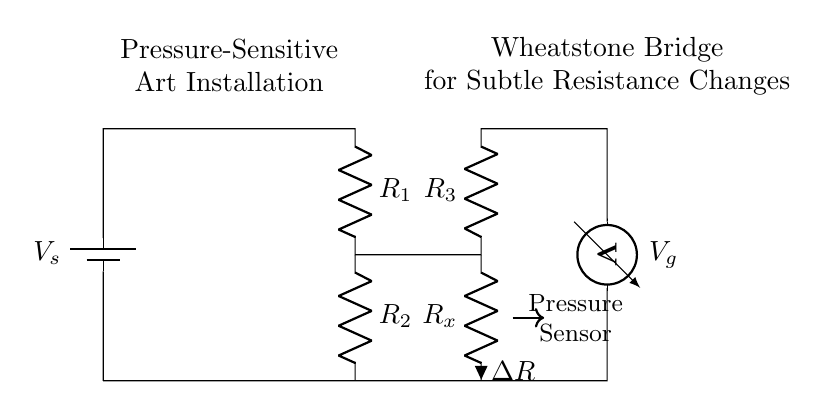What is the symbol for the power source? The power source is represented by the symbol for a battery, which is shown on the left side of the circuit diagram.
Answer: Battery What do R1 and R2 represent? R1 and R2 represent resistors in the Wheatstone bridge, which are used to form the circuit and measure resistance changes.
Answer: Resistors What component measures voltage in this circuit? The voltmeter symbol indicates the component that measures voltage, connected to the output of the Wheatstone bridge.
Answer: Voltmeter How many resistors are in the Wheatstone bridge? There are four resistors in the Wheatstone bridge circuit, comprising R1, R2, R3, and Rx.
Answer: Four What is connected to Rx? The component connected to Rx is a pressure sensor that detects changes in pressure, affecting the resistance.
Answer: Pressure sensor How does the Wheatstone bridge detect subtle resistance changes? The Wheatstone bridge detects changes in resistance by comparing the voltage across the middle of the bridge, which indicates any imbalance caused by varying resistance in Rx.
Answer: By voltage comparison 